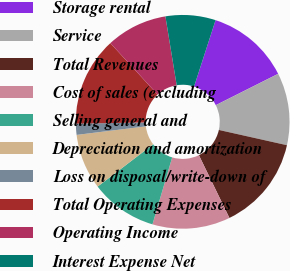<chart> <loc_0><loc_0><loc_500><loc_500><pie_chart><fcel>Storage rental<fcel>Service<fcel>Total Revenues<fcel>Cost of sales (excluding<fcel>Selling general and<fcel>Depreciation and amortization<fcel>Loss on disposal/write-down of<fcel>Total Operating Expenses<fcel>Operating Income<fcel>Interest Expense Net<nl><fcel>12.6%<fcel>10.92%<fcel>14.28%<fcel>11.76%<fcel>10.08%<fcel>8.4%<fcel>1.68%<fcel>13.44%<fcel>9.24%<fcel>7.56%<nl></chart> 